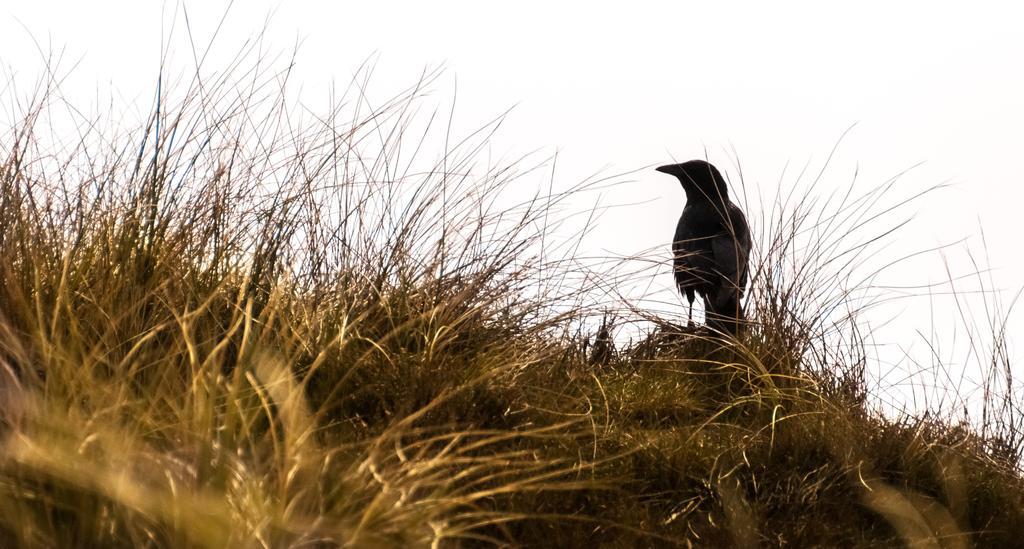How would you summarize this image in a sentence or two? In this image we can see a bird on the dry grass. In the background, we can see the sky. 